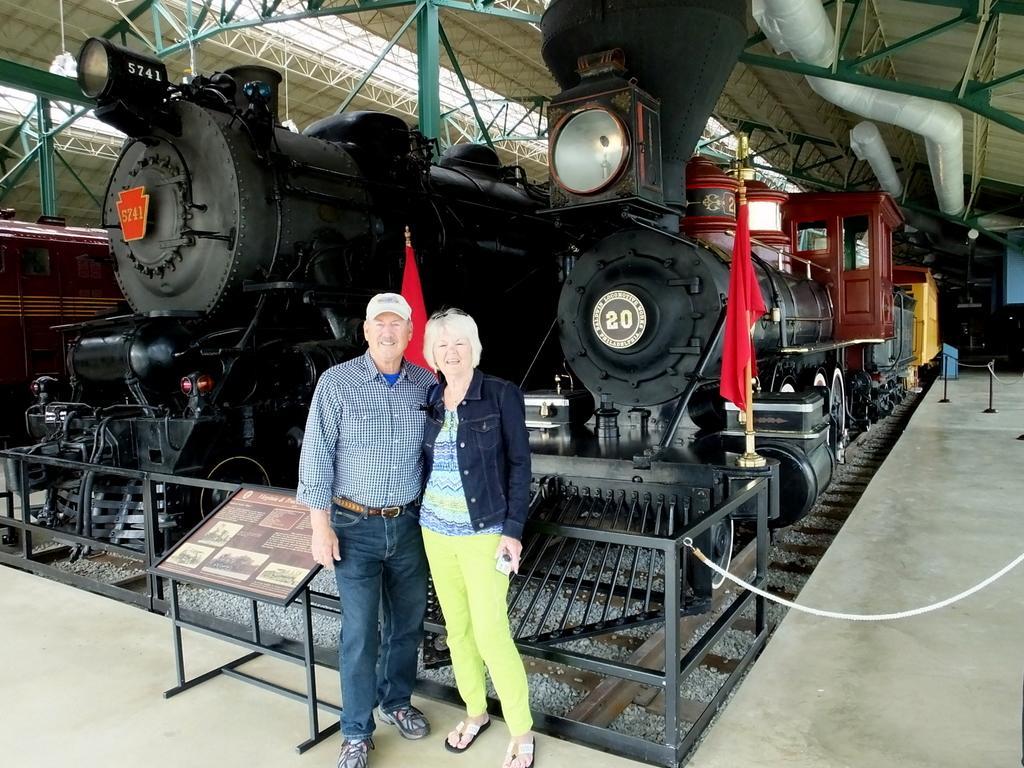Describe this image in one or two sentences. In this image there is a man and a woman standing. Beside them there is a table. There is text on the table. Behind them there is a railing. Behind the railing there are trains. At the top there is the ceiling of a shed. There are pipes to the ceiling. In front of the train there is a flag. 